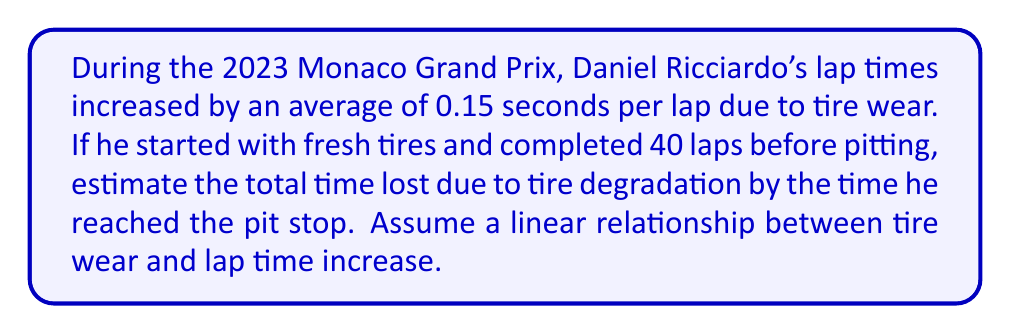Help me with this question. Let's approach this step-by-step:

1) We know that the lap time increases by 0.15 seconds per lap due to tire wear.

2) The total number of laps before pitting is 40.

3) To calculate the total time lost, we need to sum up the time increase for each lap. This forms an arithmetic sequence.

4) The formula for the sum of an arithmetic sequence is:

   $$S_n = \frac{n(a_1 + a_n)}{2}$$

   Where:
   $S_n$ is the sum of the sequence
   $n$ is the number of terms (in this case, 40 laps)
   $a_1$ is the first term (0.15 seconds for the first lap)
   $a_n$ is the last term (0.15 * 40 = 6 seconds for the 40th lap)

5) Plugging in our values:

   $$S_{40} = \frac{40(0.15 + 6)}{2}$$

6) Simplifying:

   $$S_{40} = \frac{40(6.15)}{2} = \frac{246}{2} = 123$$

Therefore, the total time lost due to tire degradation over 40 laps is 123 seconds.
Answer: 123 seconds 